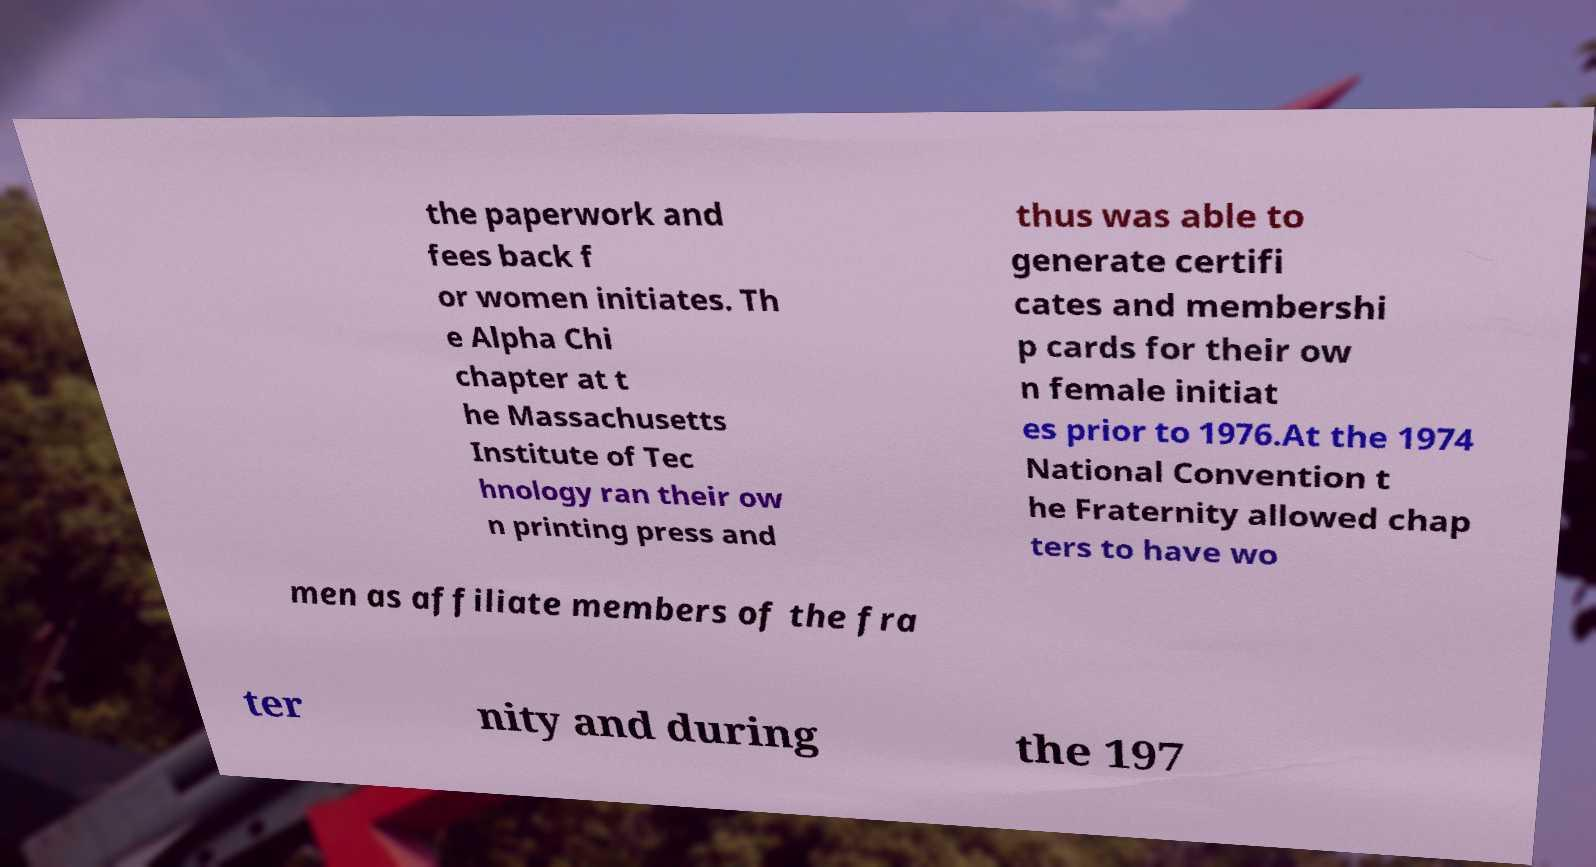Could you extract and type out the text from this image? the paperwork and fees back f or women initiates. Th e Alpha Chi chapter at t he Massachusetts Institute of Tec hnology ran their ow n printing press and thus was able to generate certifi cates and membershi p cards for their ow n female initiat es prior to 1976.At the 1974 National Convention t he Fraternity allowed chap ters to have wo men as affiliate members of the fra ter nity and during the 197 